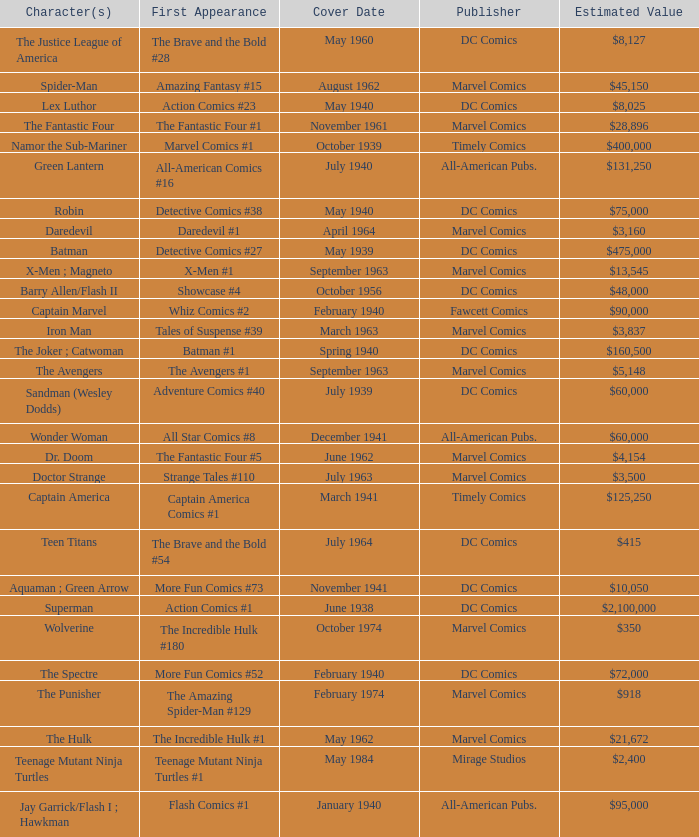Which character first appeared in Amazing Fantasy #15? Spider-Man. 